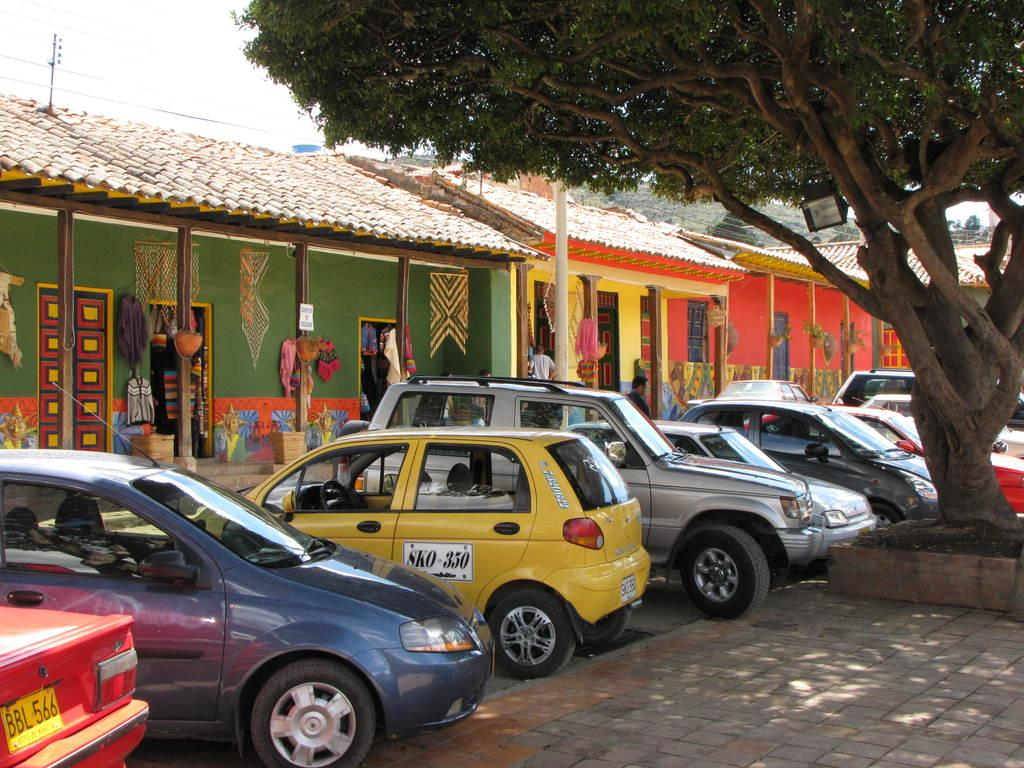<image>
Summarize the visual content of the image. A row of cars including a small yellow one that says SKO 350 on it. 